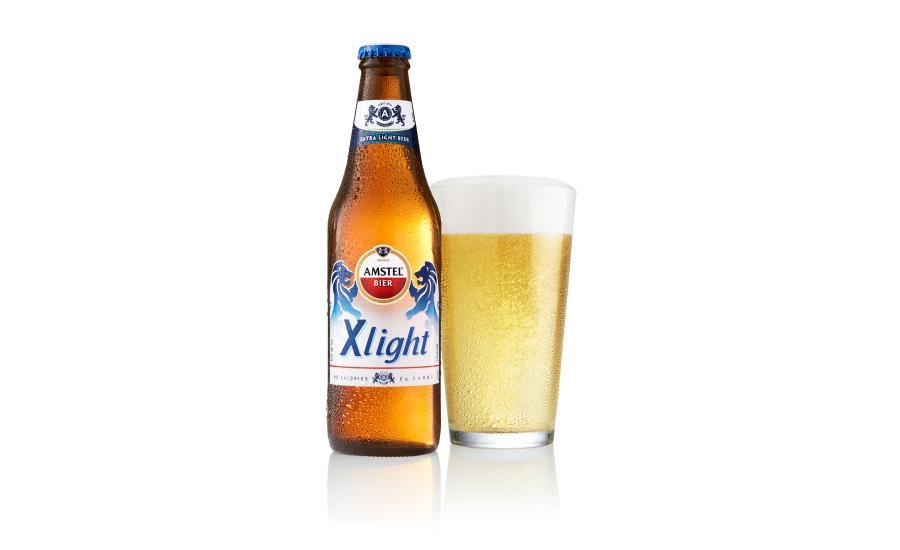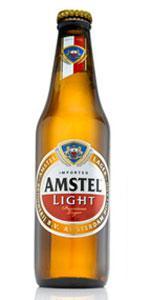The first image is the image on the left, the second image is the image on the right. Analyze the images presented: Is the assertion "There are only two bottle visible in the right image." valid? Answer yes or no. No. The first image is the image on the left, the second image is the image on the right. For the images displayed, is the sentence "In at least one image there are three bottles in a cardboard six pack holder." factually correct? Answer yes or no. No. 